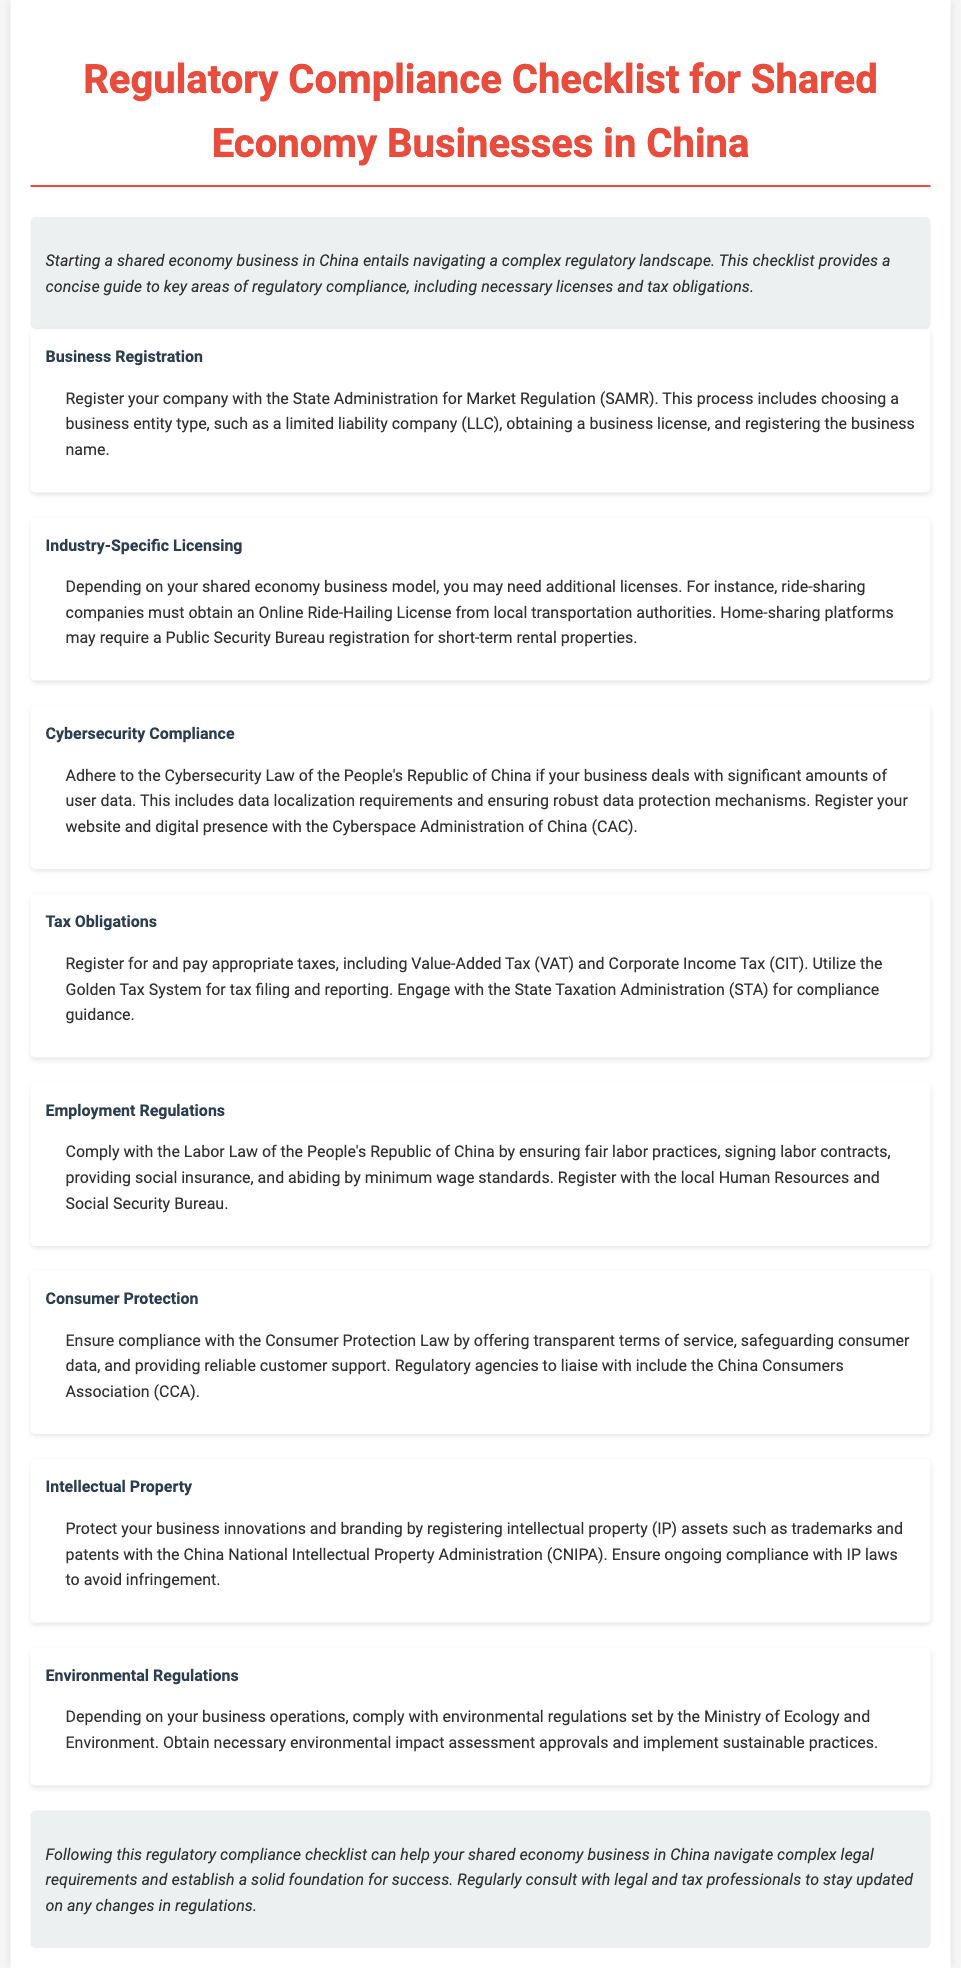What is the main regulatory body for business registration? The main regulatory body for business registration mentioned in the document is the State Administration for Market Regulation.
Answer: State Administration for Market Regulation What is required for ride-sharing companies? According to the document, ride-sharing companies must obtain a specific type of license from local transportation authorities.
Answer: Online Ride-Hailing License Which law must be adhered to for cybersecurity? The document specifies that businesses dealing with significant user data must comply with a specific Cybersecurity Law.
Answer: Cybersecurity Law of the People's Republic of China What tax must businesses register for? The document lists Value-Added Tax as one of the taxes that businesses must register and pay.
Answer: Value-Added Tax Which bureau must businesses register with for labor compliance? The document states that businesses should register with a specific bureau to comply with labor regulations.
Answer: Human Resources and Social Security Bureau What is a key consumer protection requirement? The document highlights that businesses must offer transparent terms of service as a requirement for consumer protection compliance.
Answer: Transparent terms of service What is necessary for intellectual property protection? To protect intellectual property, businesses need to register their assets with a specific administration.
Answer: China National Intellectual Property Administration Which ministry oversees environmental regulations? The document indicates that a specific ministry is responsible for environmental regulations related to business operations.
Answer: Ministry of Ecology and Environment What is the purpose of this checklist? The purpose of the checklist is to help shared economy businesses navigate legal requirements and establish a foundation for success.
Answer: Navigate complex legal requirements 